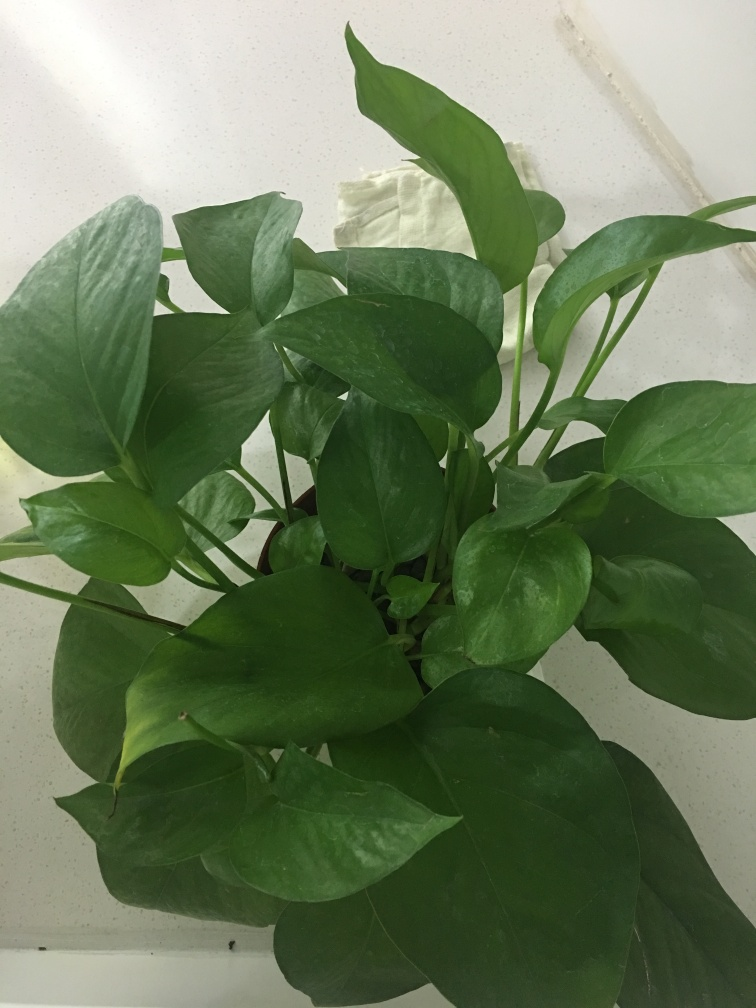Is the plant in its ideal growing environment? While the plant looks healthy, pothos plants typically thrive with indirect light and might benefit from a location where light is more diffused. The surface it's resting on seems stable, but ensuring proper drainage and consistent temperatures will further support its growth. What are some tips for taking care of indoor plants in general? General care tips for indoor plants include providing sufficient light without direct sun exposure, watering when the soil feels dry at the top, maintaining a consistent temperature, and providing occasional fertilization during the growing season. Additionally, make sure to clean the leaves to facilitate better photosynthesis. 